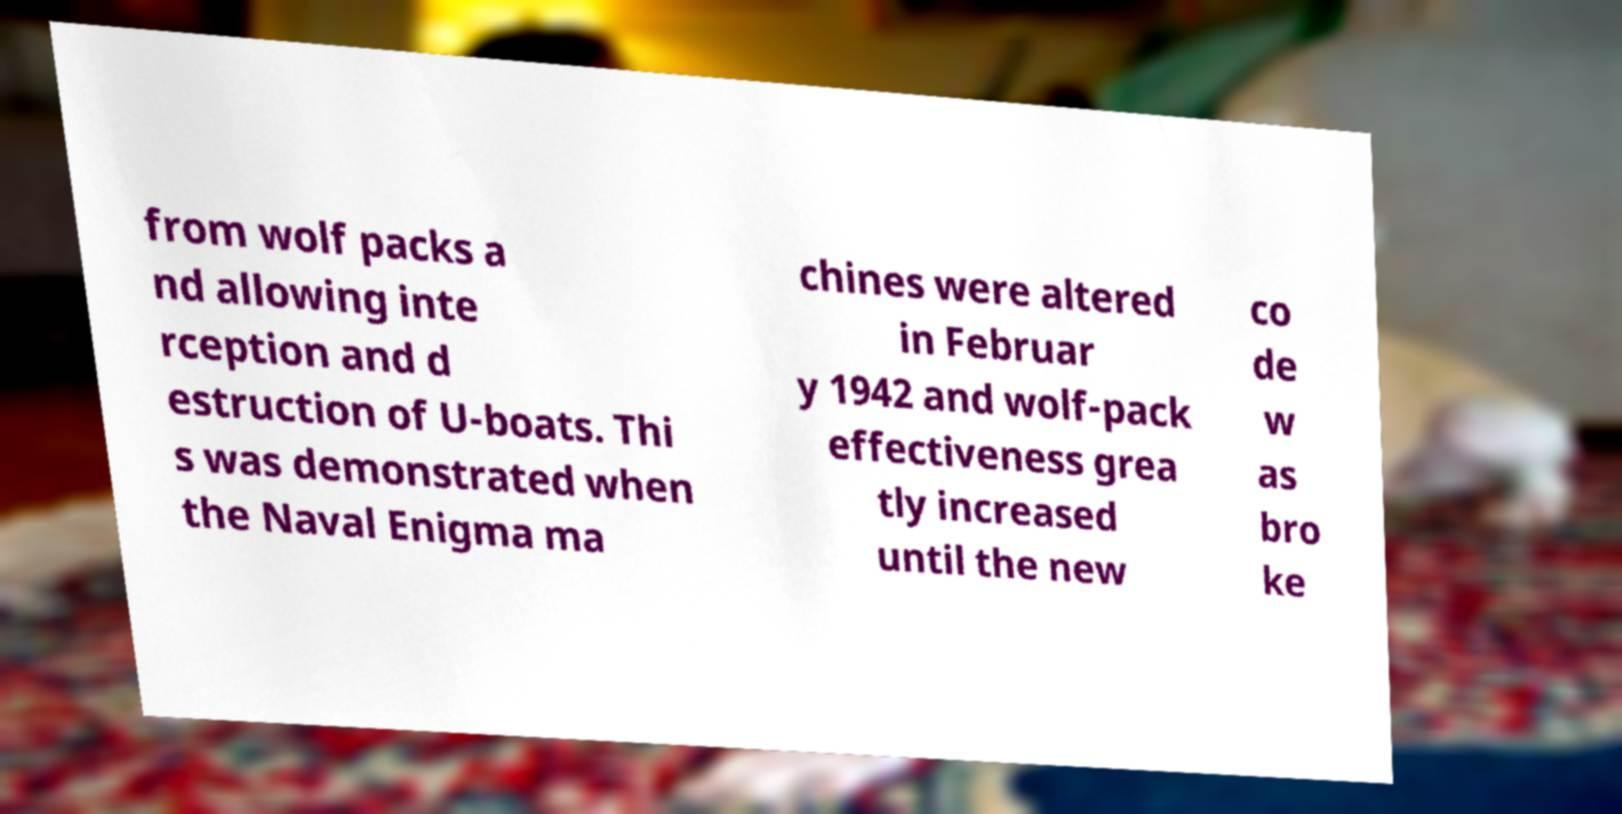Can you read and provide the text displayed in the image?This photo seems to have some interesting text. Can you extract and type it out for me? from wolf packs a nd allowing inte rception and d estruction of U-boats. Thi s was demonstrated when the Naval Enigma ma chines were altered in Februar y 1942 and wolf-pack effectiveness grea tly increased until the new co de w as bro ke 